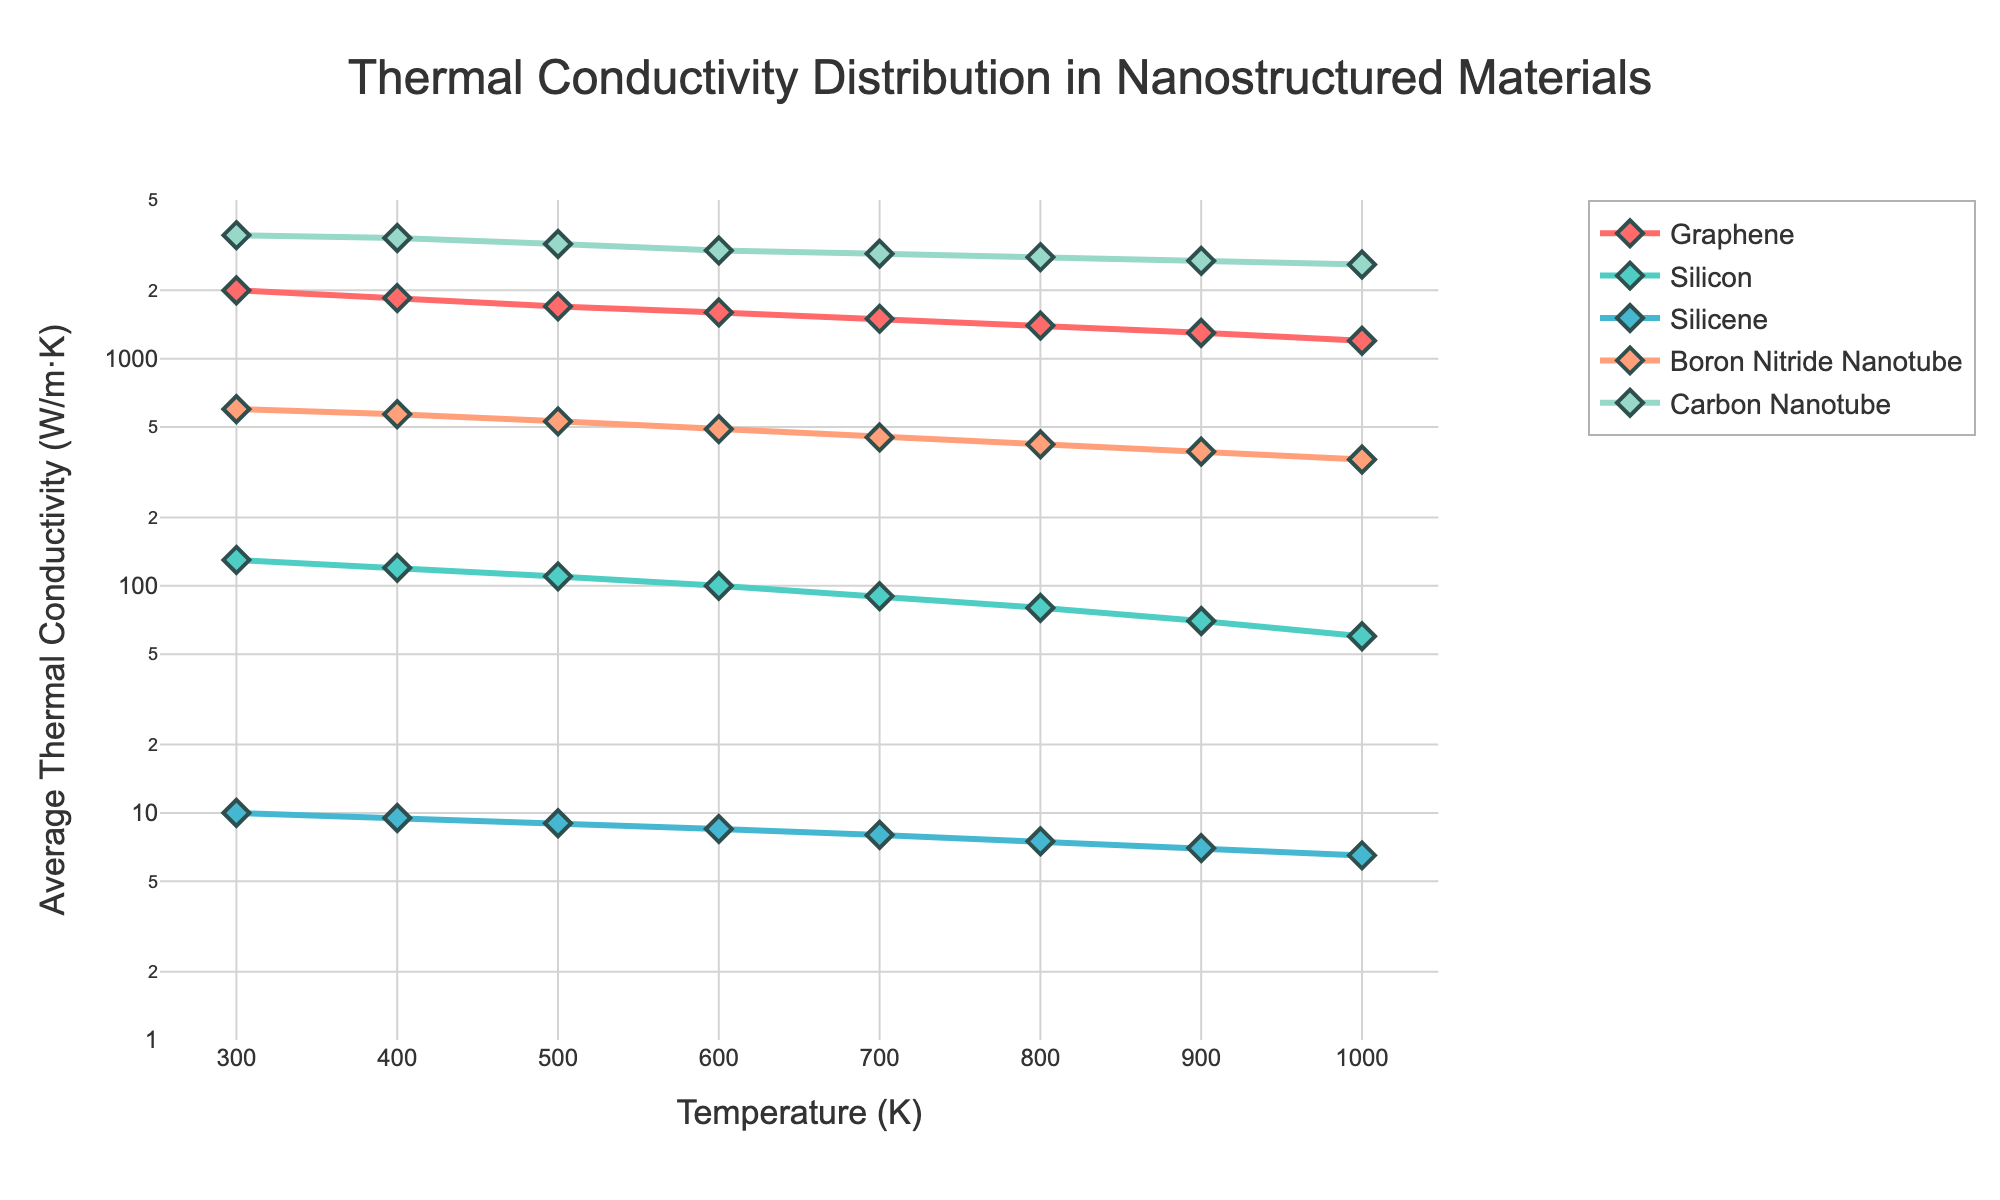What's the title of the plot? The title of the plot is usually located at the top center. By reading it, we can identify it as "Thermal Conductivity Distribution in Nanostructured Materials".
Answer: Thermal Conductivity Distribution in Nanostructured Materials What is the y-axis label? The y-axis label normally explains what is being measured along the y-axis. It is labeled as "Average Thermal Conductivity (W/m·K)".
Answer: Average Thermal Conductivity (W/m·K) Which material has the highest thermal conductivity at 700 K? To determine this, look at the data points corresponding to 700 K on the x-axis for each material. Find the material with the largest y-axis value. Carbon Nanotube has the highest value at this temperature.
Answer: Carbon Nanotube How does the thermal conductivity of Silicon change from 300 K to 1000 K? Observe the trend of Silicon's data points from 300 K to 1000 K along the x-axis. The y-axis values are decreasing from 130 W/m·K to 60 W/m·K.
Answer: It decreases Compare the thermal conductivities of Graphene and Silicene at 600 K. Which is higher and by how much? Look at the thermal conductivity values of Graphene and Silicene at 600 K. Graphene has 1600 W/m·K and Silicene has 8.5 W/m·K. Subtract the two values to find the difference. 1600 - 8.5 = 1591.5 W/m·K.
Answer: Graphene, by 1591.5 W/m·K By what factor does the thermal conductivity of Boron Nitride Nanotube increase when moving from 800 K to 300 K? Find the y-axis values for Boron Nitride Nanotube at 800 K and 300 K, which are 420 W/m·K and 600 W/m·K respectively. Divide the value at 300 K by the value at 800 K. 600 / 420 = 1.4286.
Answer: 1.43 Calculate the average thermal conductivity of Graphene across all temperatures shown. Add the thermal conductivity values of Graphene at each temperature and then divide by the number of temperatures. (2000 + 1850 + 1700 + 1600 + 1500 + 1400 + 1300 + 1200) / 8 = 1568.75.
Answer: 1568.75 W/m·K Which material has the least thermal conductivity at 500 K and what is its value? Refer to the data points corresponding to 500 K and identify the material with the lowest y-axis value. Silicene has the least value at 9.0 W/m·K.
Answer: Silicene, 9.0 W/m·K Between 400 K and 900 K, which material shows the smallest change in thermal conductivity? By comparing the change in y-axis values for each material between 400 K and 900 K:
- Graphene: 1850 to 1300 (-550)
- Silicon: 120 to 70 (-50)
- Silicene: 9.5 to 7.0 (-2.5)
- Boron Nitride Nanotube: 570 to 390 (-180)
- Carbon Nanotube: 3400 to 2700 (-700)
Silicene shows the smallest change (-2.5).
Answer: Silicene How many materials remain above 100 W/m·K at 1000 K? Identify the materials with values greater than 100 W/m·K at 1000 K. These are Graphene (1200), Boron Nitride Nanotube (360), and Carbon Nanotube (2600). There are 3 materials.
Answer: 3 